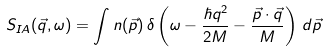Convert formula to latex. <formula><loc_0><loc_0><loc_500><loc_500>S _ { I A } ( \vec { q } , \omega ) = \int n ( \vec { p } ) \, \delta \left ( \omega - \frac { \hbar { q } ^ { 2 } } { 2 M } - \frac { \vec { p } \cdot \vec { q } } { M } \right ) \, d \vec { p } \,</formula> 